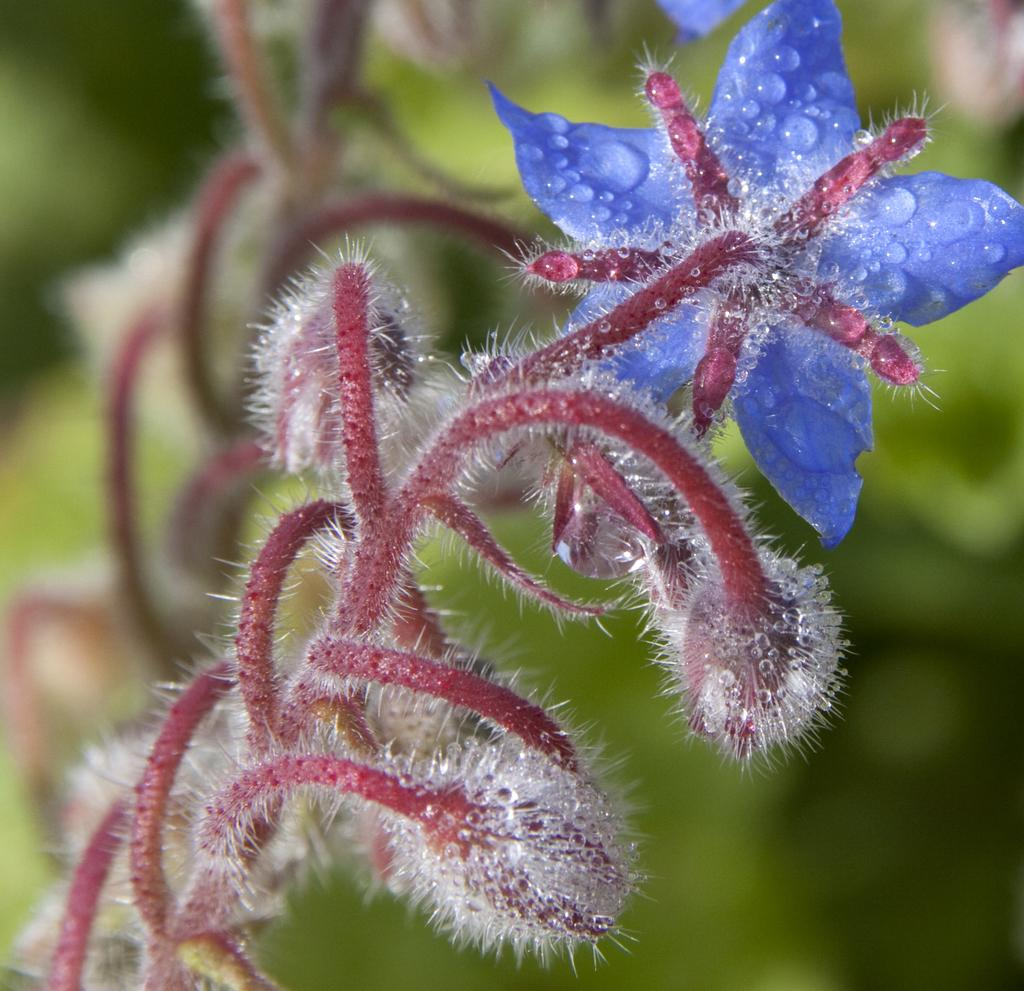What types of living organisms can be seen in the image? Plants and flowers are visible in the image. Can you describe the growth stage of some of the plants in the image? There are buds in the image, which suggests that some of the plants are in the early stages of growth. What type of acoustics can be heard in the image? There is no sound or acoustics present in the image, as it is a still photograph of plants and flowers. 